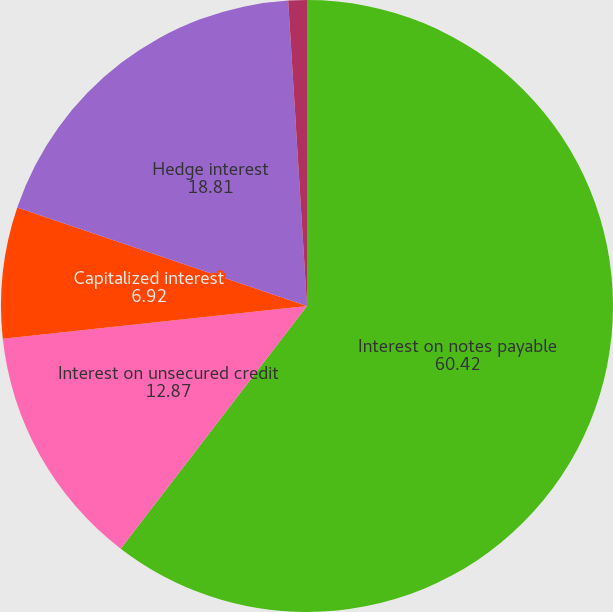Convert chart to OTSL. <chart><loc_0><loc_0><loc_500><loc_500><pie_chart><fcel>Interest on notes payable<fcel>Interest on unsecured credit<fcel>Capitalized interest<fcel>Hedge interest<fcel>Interest income<nl><fcel>60.42%<fcel>12.87%<fcel>6.92%<fcel>18.81%<fcel>0.98%<nl></chart> 